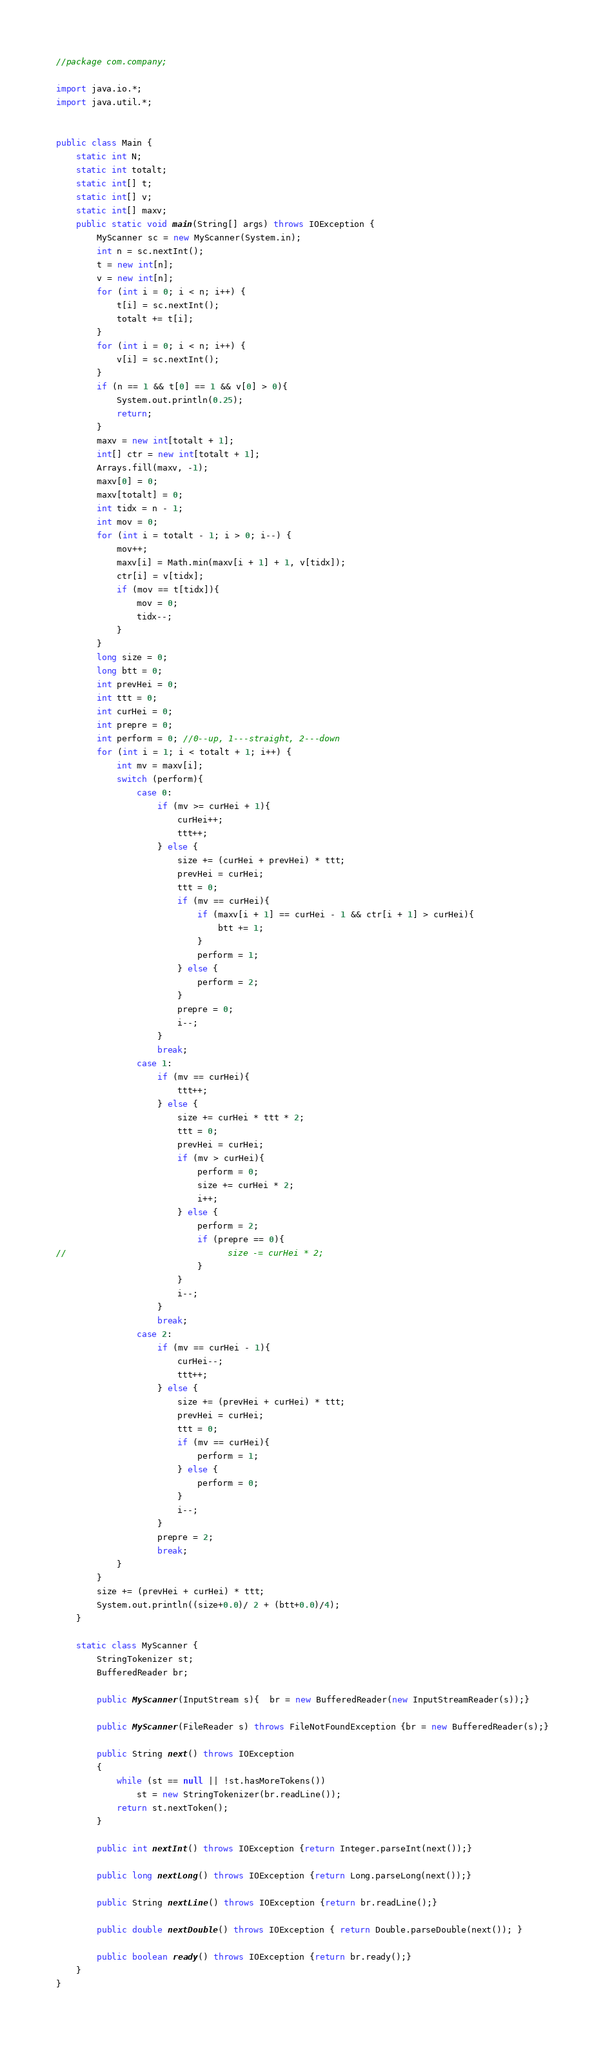Convert code to text. <code><loc_0><loc_0><loc_500><loc_500><_Java_>//package com.company;

import java.io.*;
import java.util.*;


public class Main {
    static int N;
    static int totalt;
    static int[] t;
    static int[] v;
    static int[] maxv;
    public static void main(String[] args) throws IOException {
        MyScanner sc = new MyScanner(System.in);
        int n = sc.nextInt();
        t = new int[n];
        v = new int[n];
        for (int i = 0; i < n; i++) {
            t[i] = sc.nextInt();
            totalt += t[i];
        }
        for (int i = 0; i < n; i++) {
            v[i] = sc.nextInt();
        }
        if (n == 1 && t[0] == 1 && v[0] > 0){
            System.out.println(0.25);
            return;
        }
        maxv = new int[totalt + 1];
        int[] ctr = new int[totalt + 1];
        Arrays.fill(maxv, -1);
        maxv[0] = 0;
        maxv[totalt] = 0;
        int tidx = n - 1;
        int mov = 0;
        for (int i = totalt - 1; i > 0; i--) {
            mov++;
            maxv[i] = Math.min(maxv[i + 1] + 1, v[tidx]);
            ctr[i] = v[tidx];
            if (mov == t[tidx]){
                mov = 0;
                tidx--;
            }
        }
        long size = 0;
        long btt = 0;
        int prevHei = 0;
        int ttt = 0;
        int curHei = 0;
        int prepre = 0;
        int perform = 0; //0--up, 1---straight, 2---down
        for (int i = 1; i < totalt + 1; i++) {
            int mv = maxv[i];
            switch (perform){
                case 0:
                    if (mv >= curHei + 1){
                        curHei++;
                        ttt++;
                    } else {
                        size += (curHei + prevHei) * ttt;
                        prevHei = curHei;
                        ttt = 0;
                        if (mv == curHei){
                            if (maxv[i + 1] == curHei - 1 && ctr[i + 1] > curHei){
                                btt += 1;
                            }
                            perform = 1;
                        } else {
                            perform = 2;
                        }
                        prepre = 0;
                        i--;
                    }
                    break;
                case 1:
                    if (mv == curHei){
                        ttt++;
                    } else {
                        size += curHei * ttt * 2;
                        ttt = 0;
                        prevHei = curHei;
                        if (mv > curHei){
                            perform = 0;
                            size += curHei * 2;
                            i++;
                        } else {
                            perform = 2;
                            if (prepre == 0){
//                                size -= curHei * 2;
                            }
                        }
                        i--;
                    }
                    break;
                case 2:
                    if (mv == curHei - 1){
                        curHei--;
                        ttt++;
                    } else {
                        size += (prevHei + curHei) * ttt;
                        prevHei = curHei;
                        ttt = 0;
                        if (mv == curHei){
                            perform = 1;
                        } else {
                            perform = 0;
                        }
                        i--;
                    }
                    prepre = 2;
                    break;
            }
        }
        size += (prevHei + curHei) * ttt;
        System.out.println((size+0.0)/ 2 + (btt+0.0)/4);
    }

    static class MyScanner {
        StringTokenizer st;
        BufferedReader br;

        public MyScanner(InputStream s){  br = new BufferedReader(new InputStreamReader(s));}

        public MyScanner(FileReader s) throws FileNotFoundException {br = new BufferedReader(s);}

        public String next() throws IOException
        {
            while (st == null || !st.hasMoreTokens())
                st = new StringTokenizer(br.readLine());
            return st.nextToken();
        }

        public int nextInt() throws IOException {return Integer.parseInt(next());}

        public long nextLong() throws IOException {return Long.parseLong(next());}

        public String nextLine() throws IOException {return br.readLine();}

        public double nextDouble() throws IOException { return Double.parseDouble(next()); }

        public boolean ready() throws IOException {return br.ready();}
    }
}</code> 